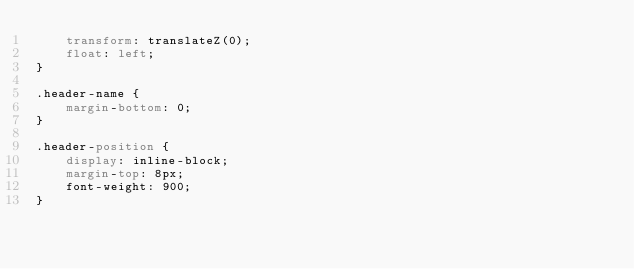<code> <loc_0><loc_0><loc_500><loc_500><_CSS_>    transform: translateZ(0);
    float: left;
}

.header-name {
    margin-bottom: 0;
}

.header-position {
    display: inline-block;
    margin-top: 8px;
    font-weight: 900;
}
</code> 